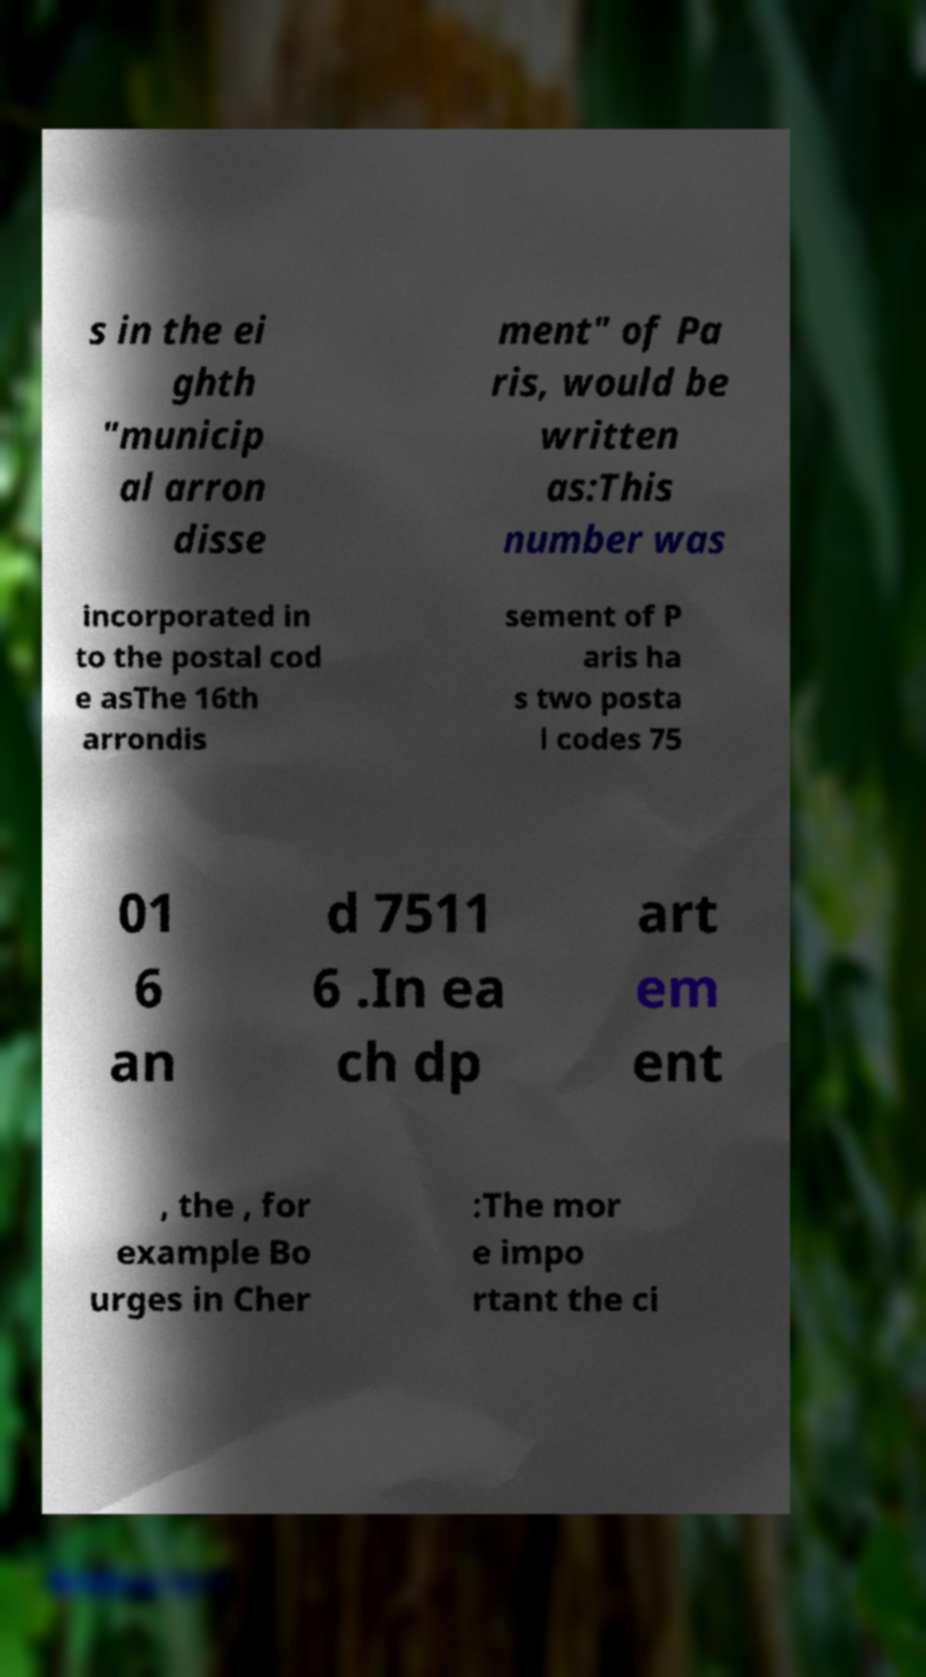Please read and relay the text visible in this image. What does it say? s in the ei ghth "municip al arron disse ment" of Pa ris, would be written as:This number was incorporated in to the postal cod e asThe 16th arrondis sement of P aris ha s two posta l codes 75 01 6 an d 7511 6 .In ea ch dp art em ent , the , for example Bo urges in Cher :The mor e impo rtant the ci 